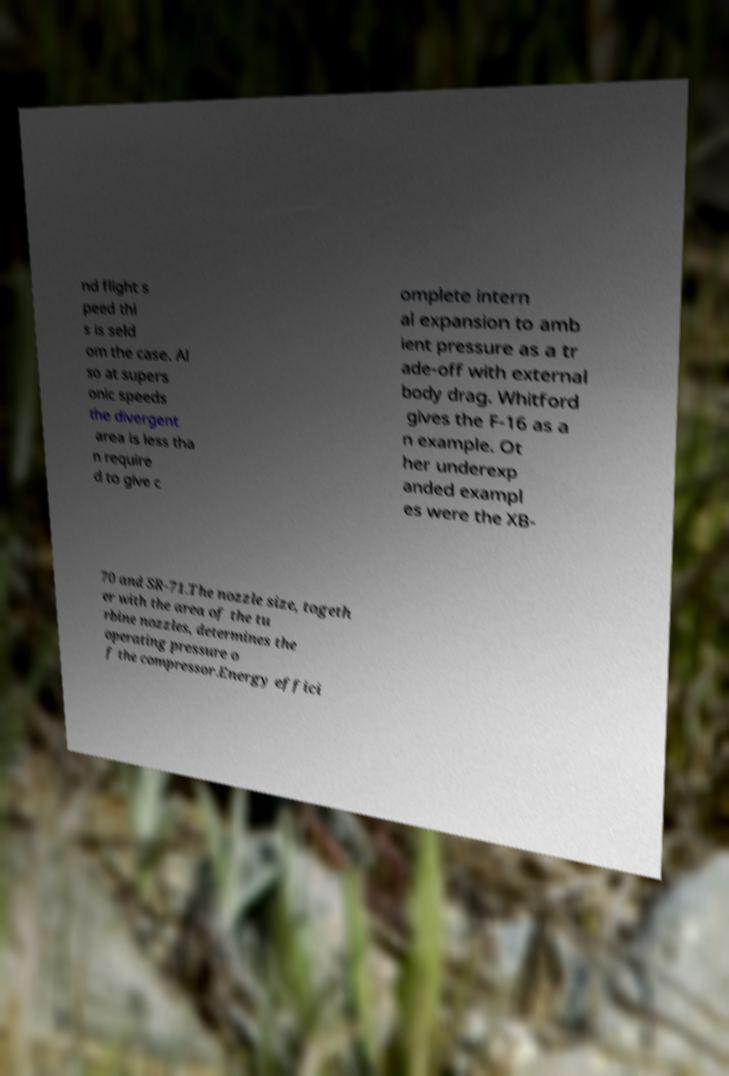What messages or text are displayed in this image? I need them in a readable, typed format. nd flight s peed thi s is seld om the case. Al so at supers onic speeds the divergent area is less tha n require d to give c omplete intern al expansion to amb ient pressure as a tr ade-off with external body drag. Whitford gives the F-16 as a n example. Ot her underexp anded exampl es were the XB- 70 and SR-71.The nozzle size, togeth er with the area of the tu rbine nozzles, determines the operating pressure o f the compressor.Energy effici 